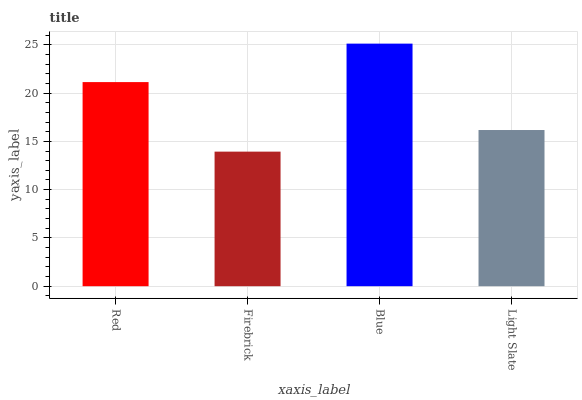Is Firebrick the minimum?
Answer yes or no. Yes. Is Blue the maximum?
Answer yes or no. Yes. Is Blue the minimum?
Answer yes or no. No. Is Firebrick the maximum?
Answer yes or no. No. Is Blue greater than Firebrick?
Answer yes or no. Yes. Is Firebrick less than Blue?
Answer yes or no. Yes. Is Firebrick greater than Blue?
Answer yes or no. No. Is Blue less than Firebrick?
Answer yes or no. No. Is Red the high median?
Answer yes or no. Yes. Is Light Slate the low median?
Answer yes or no. Yes. Is Light Slate the high median?
Answer yes or no. No. Is Red the low median?
Answer yes or no. No. 